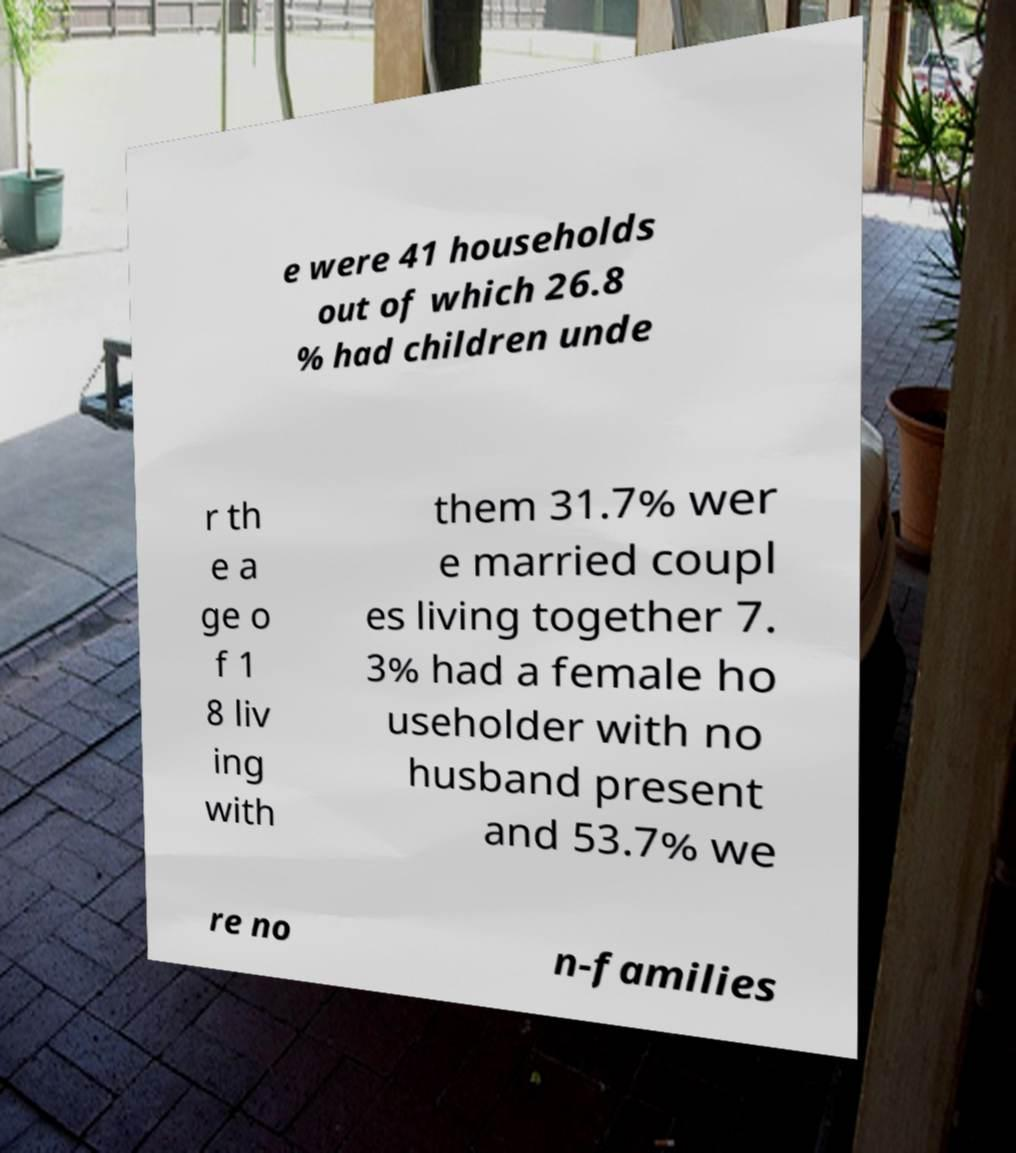Could you assist in decoding the text presented in this image and type it out clearly? e were 41 households out of which 26.8 % had children unde r th e a ge o f 1 8 liv ing with them 31.7% wer e married coupl es living together 7. 3% had a female ho useholder with no husband present and 53.7% we re no n-families 